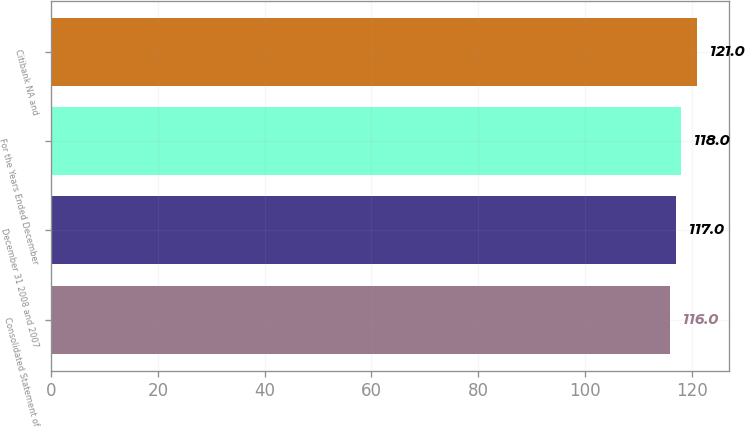<chart> <loc_0><loc_0><loc_500><loc_500><bar_chart><fcel>Consolidated Statement of<fcel>December 31 2008 and 2007<fcel>For the Years Ended December<fcel>Citibank NA and<nl><fcel>116<fcel>117<fcel>118<fcel>121<nl></chart> 